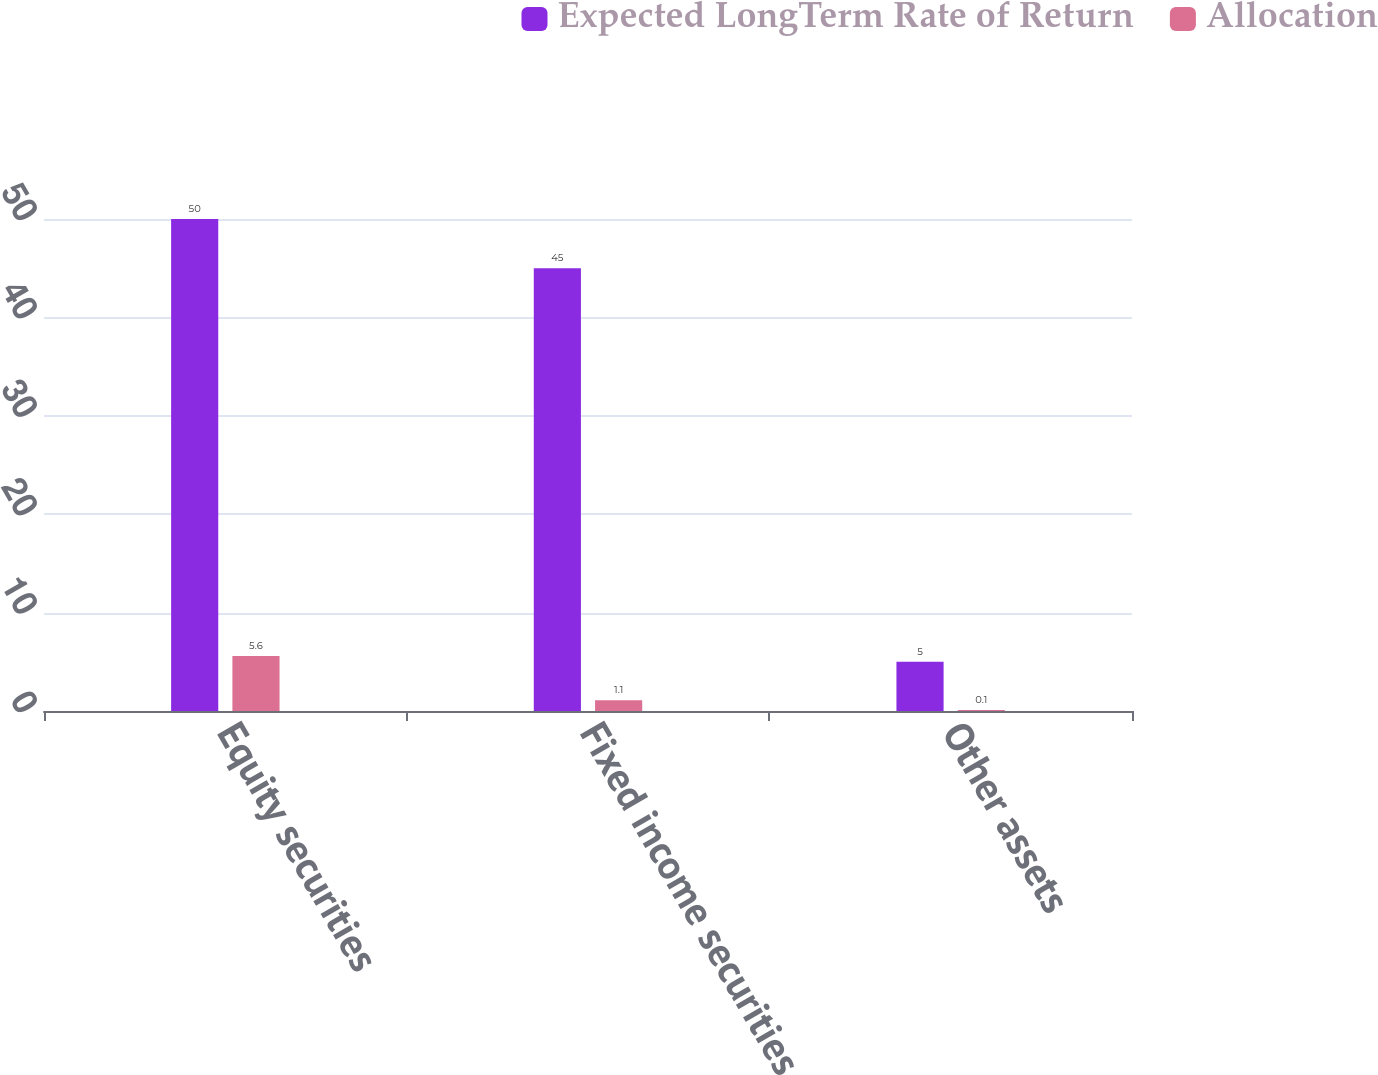Convert chart to OTSL. <chart><loc_0><loc_0><loc_500><loc_500><stacked_bar_chart><ecel><fcel>Equity securities<fcel>Fixed income securities<fcel>Other assets<nl><fcel>Expected LongTerm Rate of Return<fcel>50<fcel>45<fcel>5<nl><fcel>Allocation<fcel>5.6<fcel>1.1<fcel>0.1<nl></chart> 